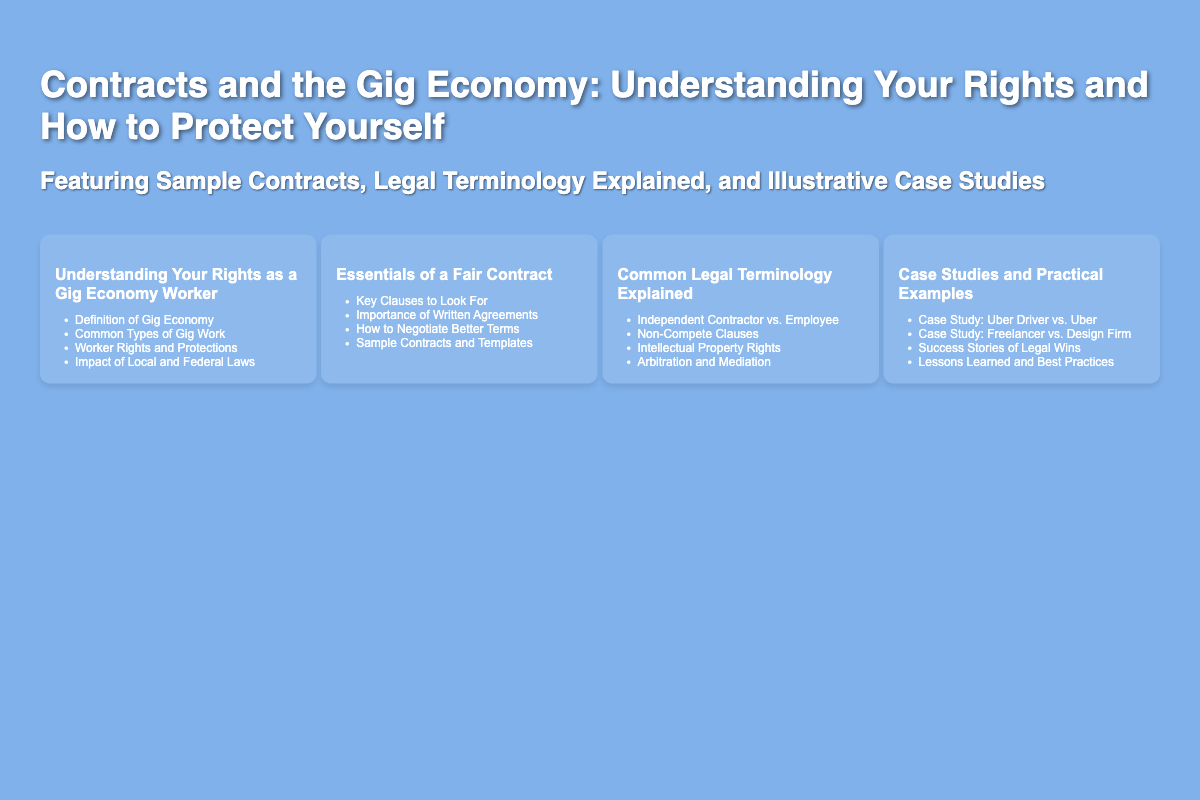what is the title of the book? The title is prominently displayed at the top of the book cover, indicating the main subject matter of the document.
Answer: Contracts and the Gig Economy: Understanding Your Rights and How to Protect Yourself who is the author of the book? The author's name is mentioned at the bottom right corner of the document, which identifies the creator of the content.
Answer: J.D. Walsh, Esq what is one of the topics covered in the book? The topics listed are located in the section displaying various key areas of discussion relevant to gig economy workers.
Answer: Understanding Your Rights as a Gig Economy Worker how many case studies are mentioned? The number of case studies is listed under the "Case Studies and Practical Examples" section of the cover.
Answer: Four what is the main purpose of the book? The subtitle clarifies the additional elements and objectives the book aims to achieve for its readers.
Answer: Understanding Your Rights and How to Protect Yourself what type of worker classification is discussed? The discussions focus on various legal distinctions that impact gig workers, which is highlighted in the "Common Legal Terminology Explained" section.
Answer: Independent Contractor vs. Employee what key aspect is emphasized when dealing with contracts? The document emphasizes the importance of specific elements one should be aware of when dealing with contracts for gig work.
Answer: Importance of Written Agreements what can readers expect to find in the book regarding contracts? The book promises to include examples that can help readers understand real-world applications of contract issues.
Answer: Sample Contracts and Templates 